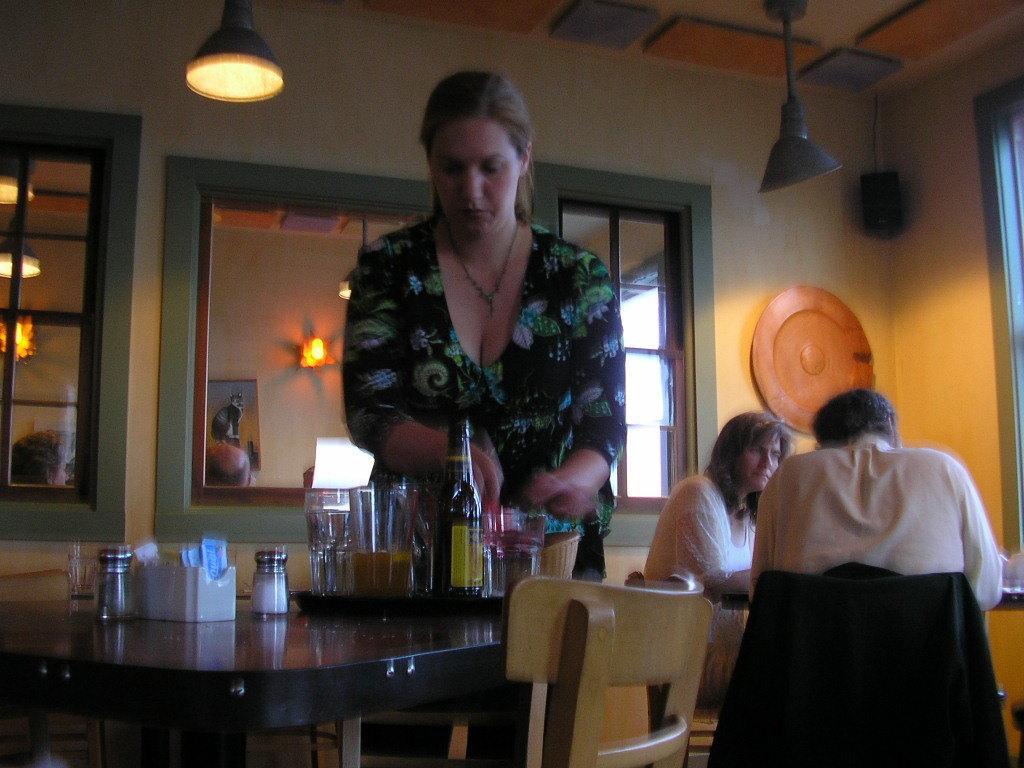Can you describe this image briefly? I can see a woman standing. This is a table with salt and pepper bottles,a tray with tumbler,beer bottle placed on the table. There are two persons sitting on the chairs. This is a mirror attached to the wall. This is a lamp hanging through the ceiling rooftop. This looks like a window. I think this is a speaker attached to the wall. 